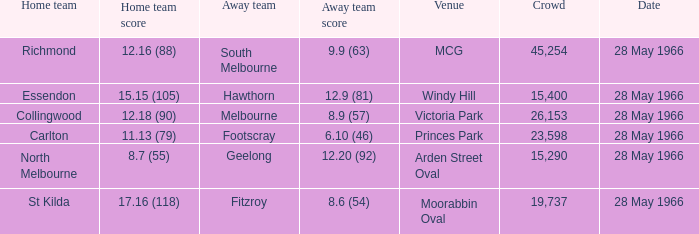Which location has a home team of essendon? Windy Hill. 